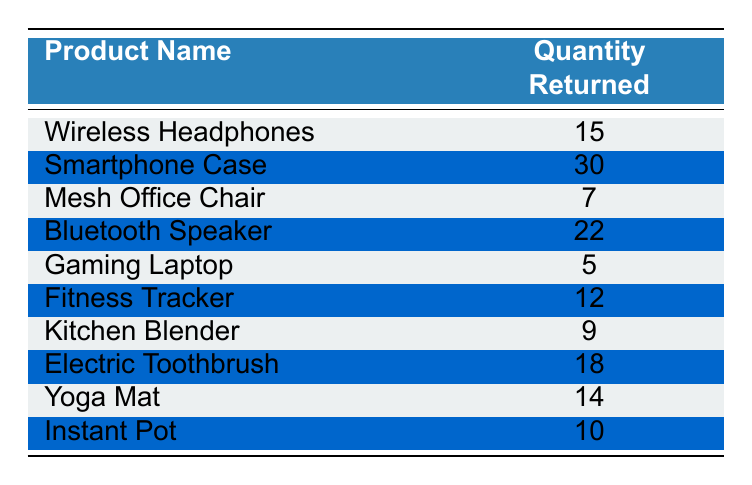What is the product with the highest quantity returned? The table lists various products along with the quantity returned. By scanning through the quantity values, we see that the "Smartphone Case" has the highest value of 30.
Answer: Smartphone Case How many products had 10 or more returns? We filter through the table to count products with quantities of 10 or more. The qualifying products are "Smartphone Case" (30), "Bluetooth Speaker" (22), "Electric Toothbrush" (18), "Wireless Headphones" (15), "Yoga Mat" (14), and "Instant Pot" (10), totaling 6 products.
Answer: 6 What is the sum of returns for all products? We sum up all the returned quantities: 15 + 30 + 7 + 22 + 5 + 12 + 9 + 18 + 14 + 10 =  142.
Answer: 142 Is the quantity returned for the "Gaming Laptop" more than the quantity returned for the "Instant Pot"? The "Gaming Laptop" has a quantity of 5, and the "Instant Pot" has a quantity of 10. Since 5 is not greater than 10, the statement is false.
Answer: No What is the average return quantity among the products listed? To find the average, we take the total quantity returned, which is 142 (as calculated earlier), and divide it by the number of products, which is 10: 142 / 10 = 14.2.
Answer: 14.2 Which two products had the least returns, and what is their combined quantity? The least returns are for "Gaming Laptop" with 5 and "Mesh Office Chair" with 7. Their combined quantity is 5 + 7 = 12.
Answer: 12 Are there any products listed that had fewer than 10 returns? Scanning the table shows that the "Gaming Laptop" (5) and "Mesh Office Chair" (7) both had fewer than 10 returns. Thus, the statement is true.
Answer: Yes Which product had 12 returns, and how does it rank compared to products with more returns? The "Fitness Tracker" has 12 returns. It ranks lower than products like "Smartphone Case" (30), "Bluetooth Speaker" (22), and "Electric Toothbrush" (18) but higher than "Wireless Headphones" (15) and others with fewer returns.
Answer: Fitness Tracker, ranked 5th 